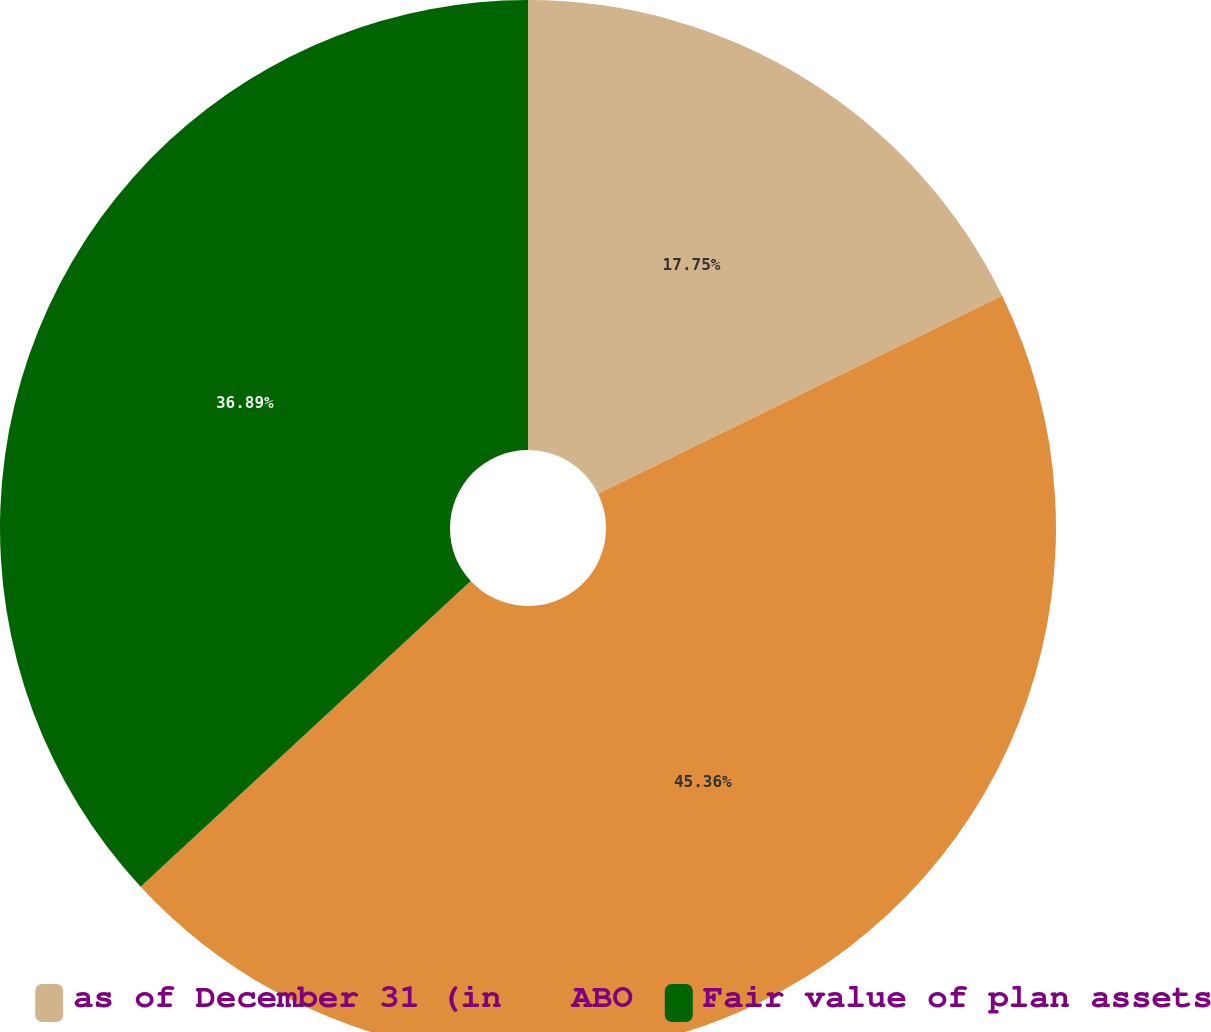Convert chart to OTSL. <chart><loc_0><loc_0><loc_500><loc_500><pie_chart><fcel>as of December 31 (in<fcel>ABO<fcel>Fair value of plan assets<nl><fcel>17.75%<fcel>45.36%<fcel>36.89%<nl></chart> 